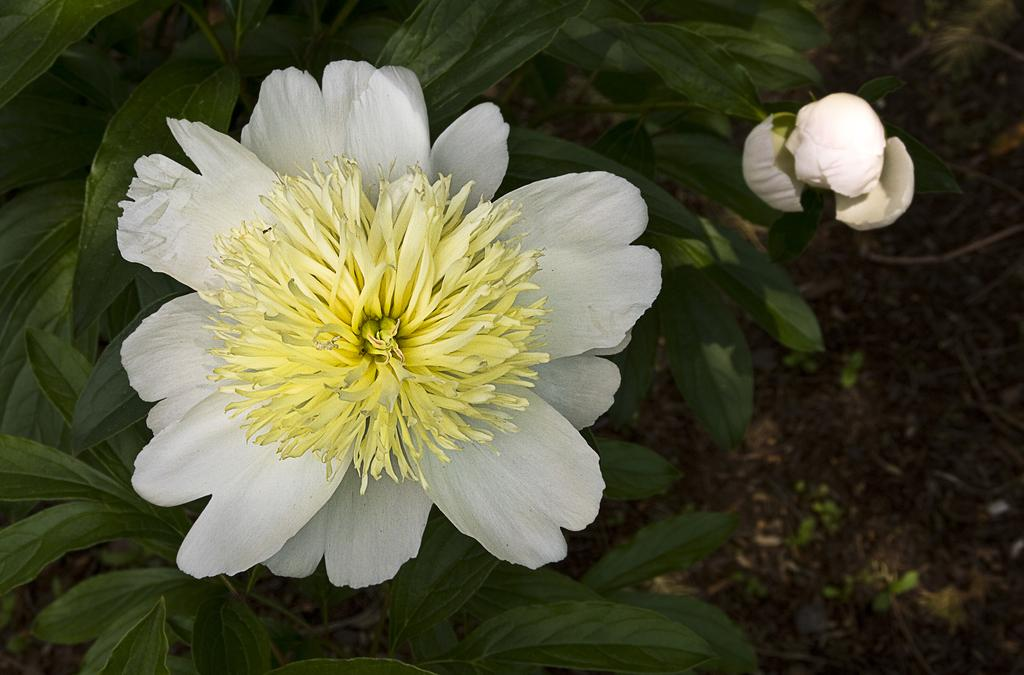How many flowers can be seen in the image? There are two flowers in the image. What else can be seen in the image besides the flowers? There is a plant in the background of the image. What type of bridge can be seen connecting the two flowers in the image? There is no bridge present in the image; it only features two flowers and a plant in the background. 